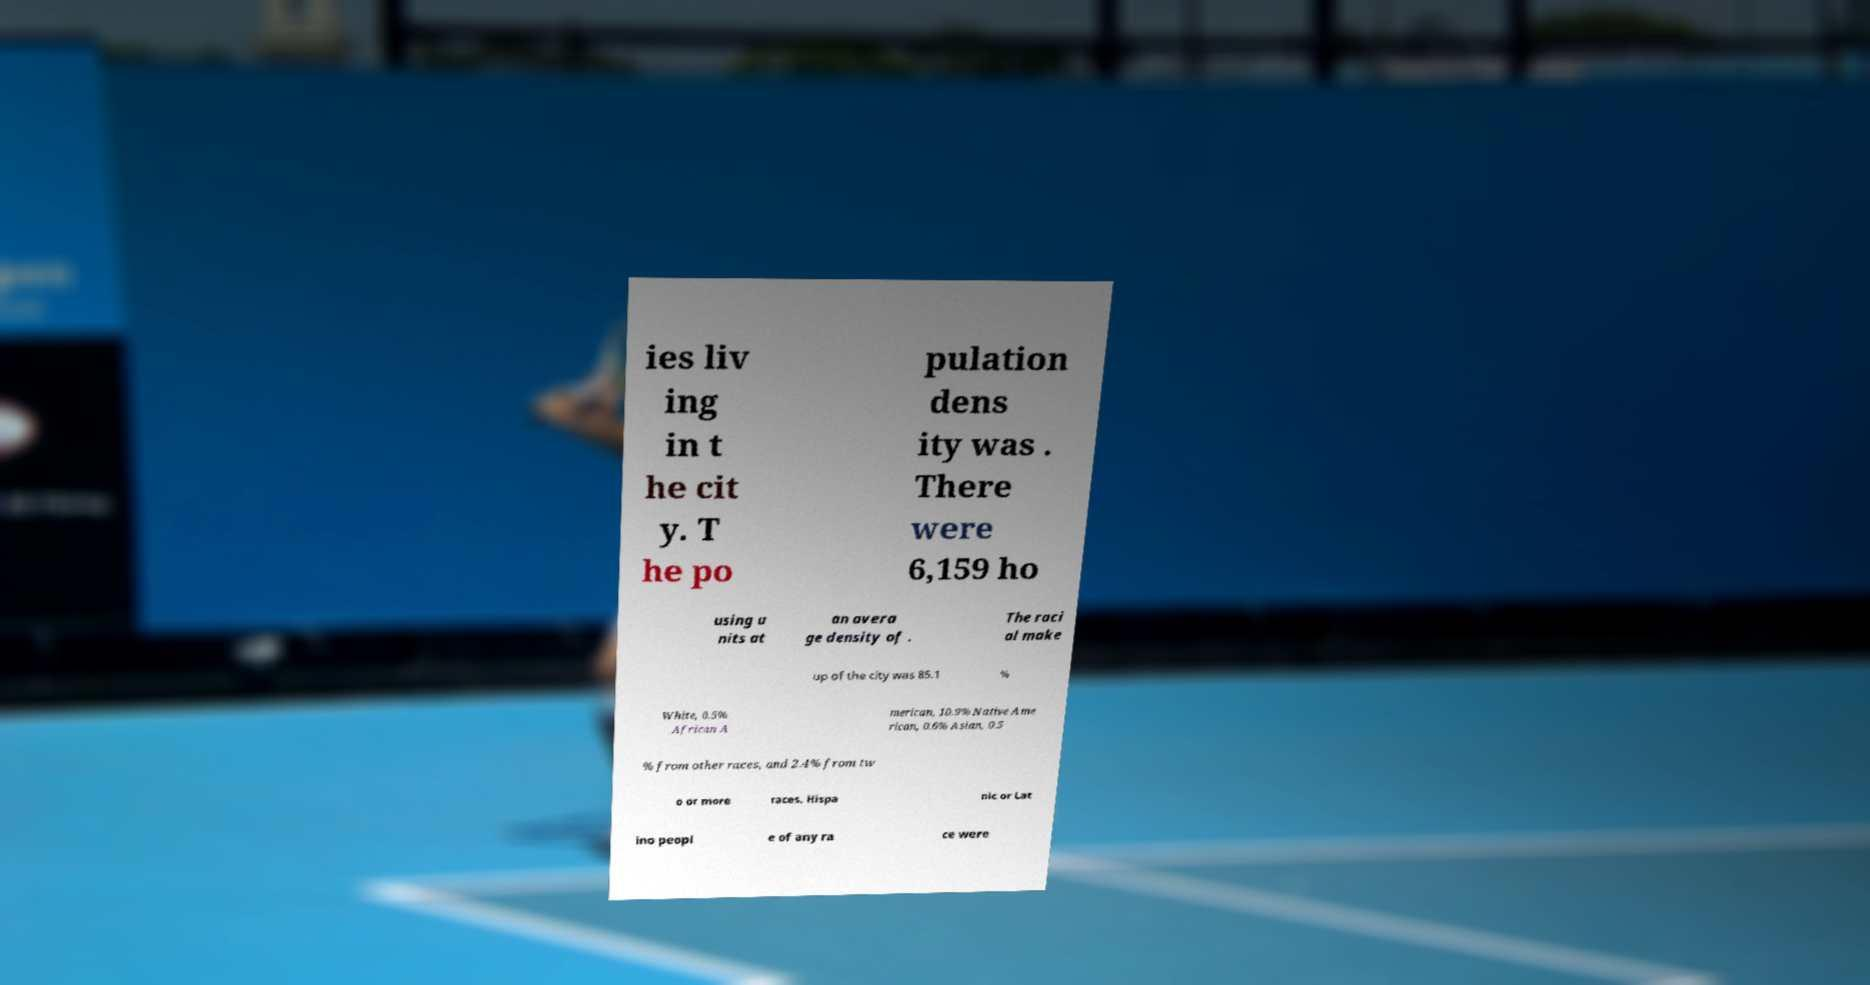Could you assist in decoding the text presented in this image and type it out clearly? ies liv ing in t he cit y. T he po pulation dens ity was . There were 6,159 ho using u nits at an avera ge density of . The raci al make up of the city was 85.1 % White, 0.5% African A merican, 10.9% Native Ame rican, 0.6% Asian, 0.5 % from other races, and 2.4% from tw o or more races. Hispa nic or Lat ino peopl e of any ra ce were 